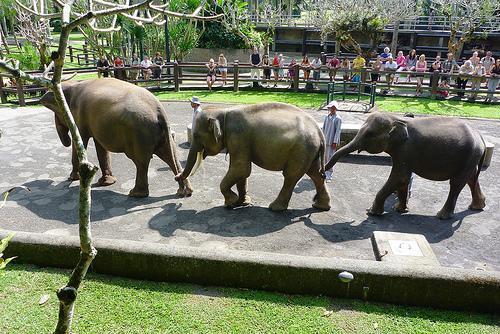How many elephants are in the picture?
Give a very brief answer. 3. How many elephants are there?
Give a very brief answer. 3. How many people are managing the elephants?
Give a very brief answer. 2. How many trees are in the foreground?
Give a very brief answer. 1. How many tails can you see?
Give a very brief answer. 3. How many elephants?
Give a very brief answer. 3. How many shadows are on the road?
Give a very brief answer. 3. 